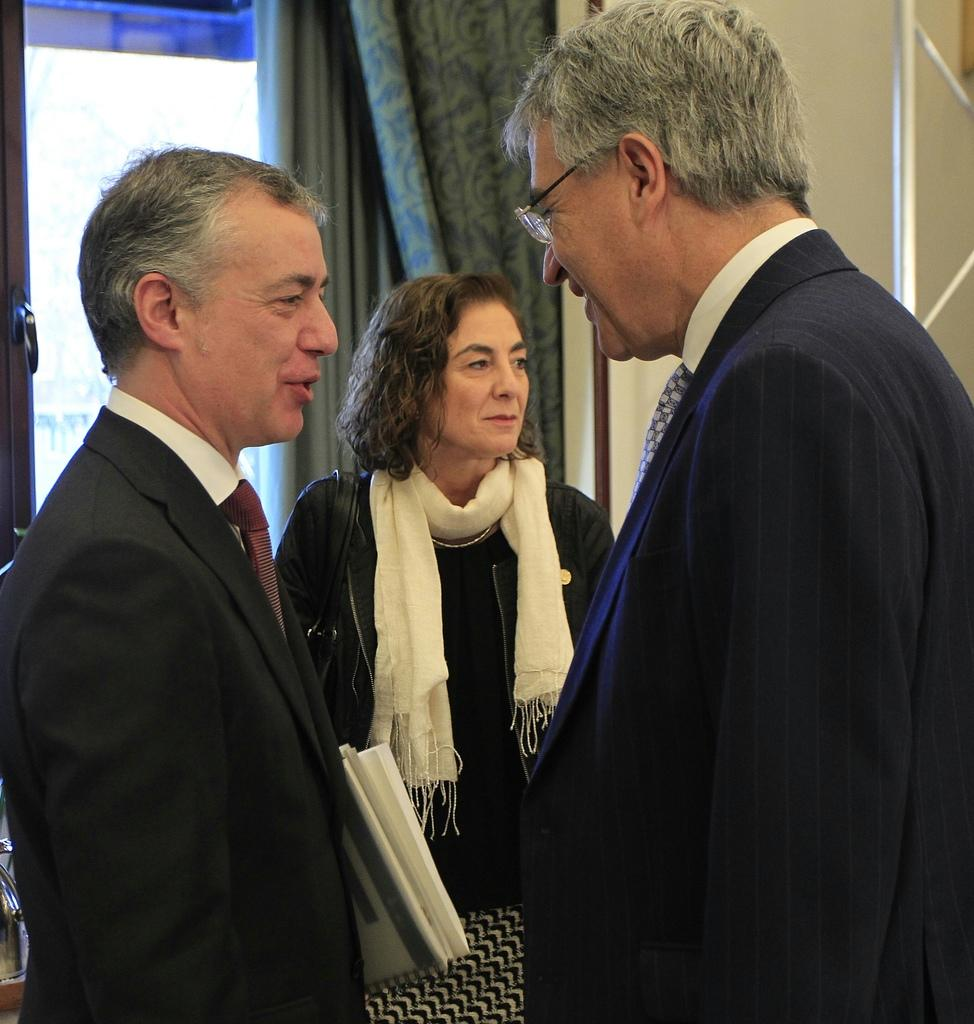How many people are present in the image? There are people standing in the image. What is one person holding in the image? One person is holding papers. Can you describe the window in the image? There is a window in the image, and it is on a wall. What is associated with the window in the image? There is a curtain associated with the window. What type of copy machine is present in the image? There is no copy machine present in the image. What type of army is depicted in the image? There is no army depicted in the image. 